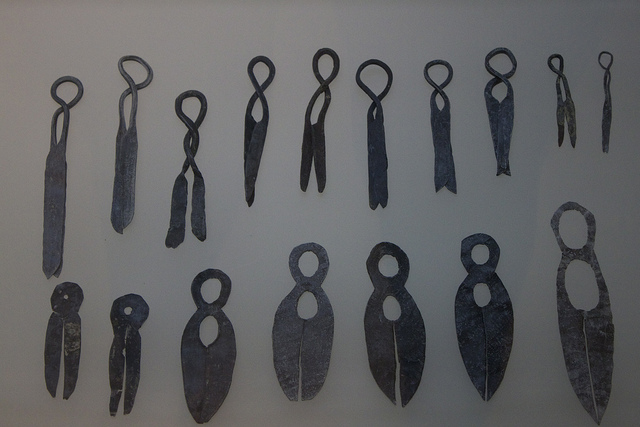<image>What are the objects displayed? I don't know all the objects displayed in the image. However, scissors or shears could be displayed. What are the objects displayed? I am not sure what objects are displayed. It can be seen scissors, shears, or tools. 